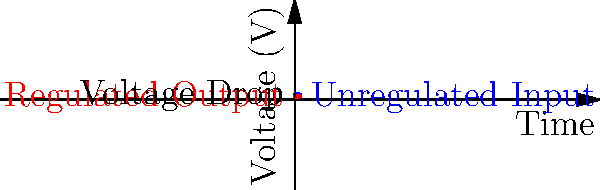In designing a basic voltage regulator for spacecraft power systems, a common requirement is to convert an unregulated 5V input to a stable 3.3V output. Given this scenario, what type of voltage regulator would be most suitable, and what is the primary concern when selecting components for this application? To answer this question, let's consider the following steps:

1. Voltage Conversion:
   The requirement is to convert 5V to 3.3V, which involves stepping down the voltage.

2. Regulator Types:
   There are two main types of voltage regulators:
   a) Linear regulators
   b) Switching regulators

3. Suitability for Spacecraft:
   For spacecraft applications, efficiency is crucial due to limited power resources.

4. Efficiency Calculation:
   For a linear regulator:
   Efficiency = $\frac{V_{out}}{V_{in}} \times 100\%$ = $\frac{3.3V}{5V} \times 100\%$ = 66%

   This means 34% of power is wasted as heat.

5. Heat Dissipation:
   In space, heat dissipation is challenging due to the vacuum environment.

6. Switching Regulator Advantage:
   Switching regulators can achieve much higher efficiencies, often >90%.

7. Primary Concern:
   The main concern in spacecraft applications is radiation hardness. Components must be able to withstand the harsh radiation environment of space.

8. Conclusion:
   A radiation-hardened switching regulator would be the most suitable choice for this application.
Answer: Radiation-hardened switching regulator 